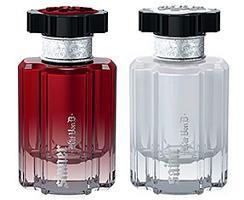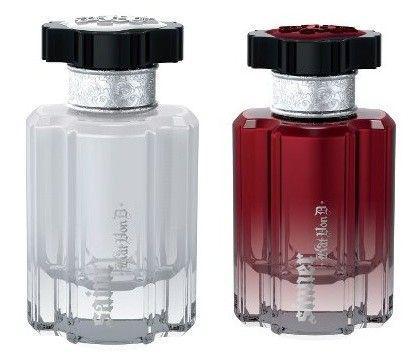The first image is the image on the left, the second image is the image on the right. For the images shown, is this caption "One image shows a container of perfume and the box it is sold in, while a second image shows two or more bottles of cologne arranged side by side." true? Answer yes or no. No. The first image is the image on the left, the second image is the image on the right. Examine the images to the left and right. Is the description "At least one image contains a richly colored glass bottle with a sculpted shape." accurate? Answer yes or no. Yes. 